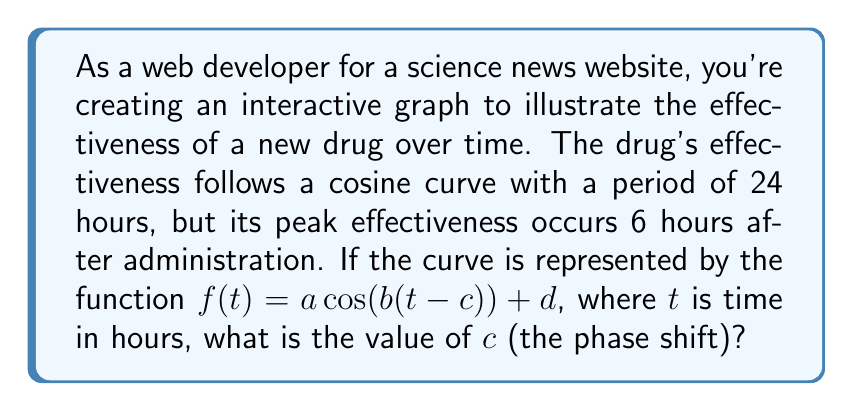Show me your answer to this math problem. Let's approach this step-by-step:

1) The general form of a cosine function is:
   $$f(t) = a \cos(b(t-c)) + d$$
   where:
   - $a$ is the amplitude
   - $b$ is the angular frequency
   - $c$ is the phase shift
   - $d$ is the vertical shift

2) We're concerned with the phase shift $c$. In a standard cosine function, the peak occurs at $t=0$. The phase shift moves this peak.

3) We're told that the peak effectiveness occurs 6 hours after administration. This means we need to shift the cosine curve 6 units to the right.

4) To shift a cosine curve to the right, we subtract from $t$ inside the parentheses. So, our $c$ value will be positive.

5) The period of the function is 24 hours. In a standard cosine function, the period is $2\pi$. To adjust for this:

   $$b = \frac{2\pi}{24} = \frac{\pi}{12}$$

6) However, the value of $b$ doesn't affect the phase shift directly.

7) Since the peak is occurring 6 hours after administration, the phase shift $c$ is simply 6.
Answer: $c = 6$ 